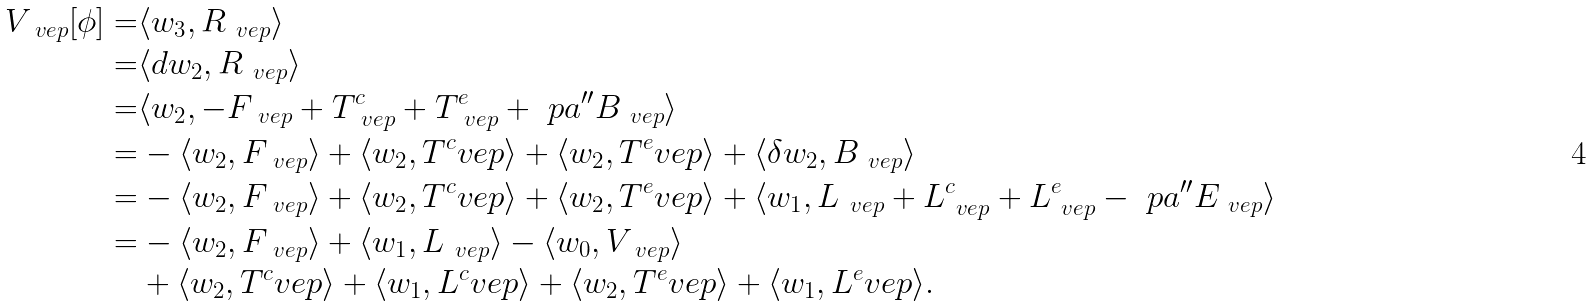Convert formula to latex. <formula><loc_0><loc_0><loc_500><loc_500>V _ { \ v e p } [ \phi ] = & \langle w _ { 3 } , R _ { \ v e p } \rangle \\ = & \langle d w _ { 2 } , R _ { \ v e p } \rangle \\ = & \langle w _ { 2 } , - F _ { \ v e p } + T _ { \ v e p } ^ { c } + T _ { \ v e p } ^ { e } + \ p a ^ { \prime \prime } B _ { \ v e p } \rangle \\ = & - \langle w _ { 2 } , F _ { \ v e p } \rangle + \langle w _ { 2 } , T ^ { c } _ { \ } v e p \rangle + \langle w _ { 2 } , T ^ { e } _ { \ } v e p \rangle + \langle \delta w _ { 2 } , B _ { \ v e p } \rangle \\ = & - \langle w _ { 2 } , F _ { \ v e p } \rangle + \langle w _ { 2 } , T ^ { c } _ { \ } v e p \rangle + \langle w _ { 2 } , T ^ { e } _ { \ } v e p \rangle + \langle w _ { 1 } , L _ { \ v e p } + L _ { \ v e p } ^ { c } + L _ { \ v e p } ^ { e } - \ p a ^ { \prime \prime } E _ { \ v e p } \rangle \\ = & - \langle w _ { 2 } , F _ { \ v e p } \rangle + \langle w _ { 1 } , L _ { \ v e p } \rangle - \langle w _ { 0 } , V _ { \ v e p } \rangle \\ & + \langle w _ { 2 } , T ^ { c } _ { \ } v e p \rangle + \langle w _ { 1 } , L ^ { c } _ { \ } v e p \rangle + \langle w _ { 2 } , T ^ { e } _ { \ } v e p \rangle + \langle w _ { 1 } , L ^ { e } _ { \ } v e p \rangle .</formula> 